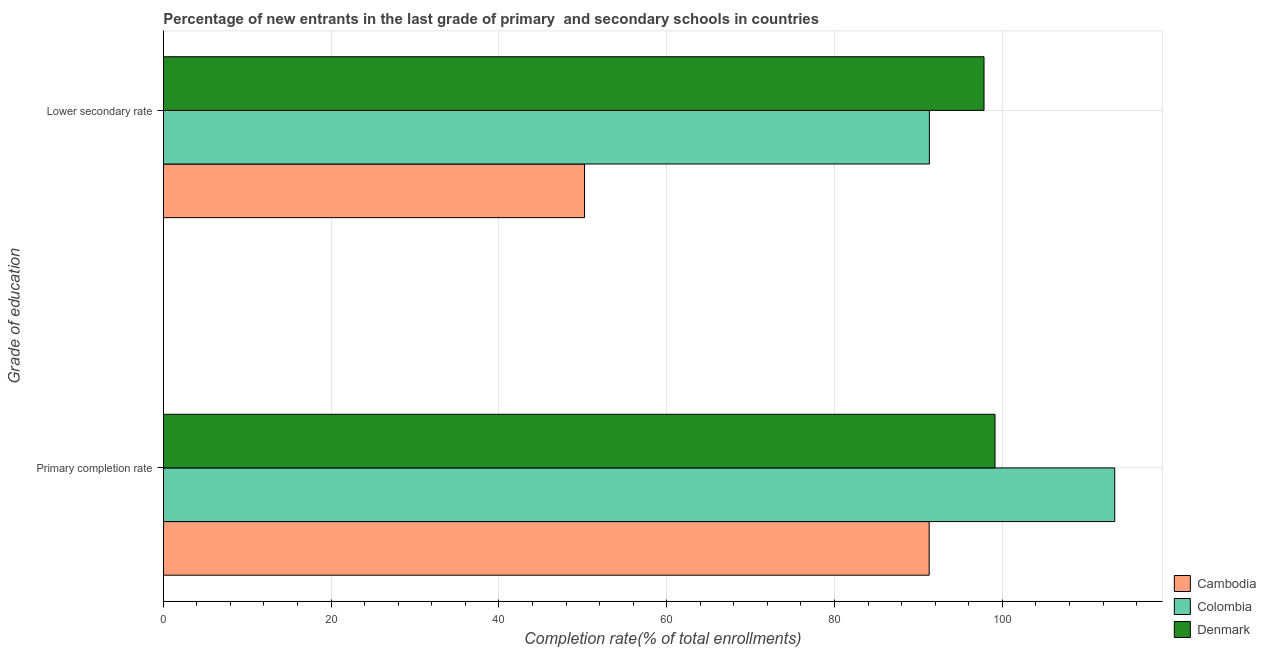How many different coloured bars are there?
Provide a short and direct response. 3. Are the number of bars per tick equal to the number of legend labels?
Provide a succinct answer. Yes. Are the number of bars on each tick of the Y-axis equal?
Your answer should be compact. Yes. How many bars are there on the 1st tick from the top?
Your answer should be very brief. 3. How many bars are there on the 2nd tick from the bottom?
Offer a very short reply. 3. What is the label of the 1st group of bars from the top?
Keep it short and to the point. Lower secondary rate. What is the completion rate in secondary schools in Cambodia?
Ensure brevity in your answer.  50.21. Across all countries, what is the maximum completion rate in primary schools?
Your response must be concise. 113.39. Across all countries, what is the minimum completion rate in secondary schools?
Provide a succinct answer. 50.21. In which country was the completion rate in primary schools maximum?
Ensure brevity in your answer.  Colombia. In which country was the completion rate in primary schools minimum?
Ensure brevity in your answer.  Cambodia. What is the total completion rate in secondary schools in the graph?
Your answer should be compact. 239.32. What is the difference between the completion rate in secondary schools in Colombia and that in Denmark?
Offer a terse response. -6.51. What is the difference between the completion rate in primary schools in Denmark and the completion rate in secondary schools in Colombia?
Your answer should be compact. 7.82. What is the average completion rate in secondary schools per country?
Offer a very short reply. 79.77. What is the difference between the completion rate in primary schools and completion rate in secondary schools in Colombia?
Ensure brevity in your answer.  22.09. What is the ratio of the completion rate in primary schools in Denmark to that in Colombia?
Offer a terse response. 0.87. Is the completion rate in secondary schools in Colombia less than that in Cambodia?
Offer a terse response. No. What does the 2nd bar from the top in Primary completion rate represents?
Your answer should be compact. Colombia. How many bars are there?
Offer a terse response. 6. Are all the bars in the graph horizontal?
Your response must be concise. Yes. Are the values on the major ticks of X-axis written in scientific E-notation?
Your answer should be compact. No. Does the graph contain any zero values?
Your answer should be compact. No. Where does the legend appear in the graph?
Your answer should be very brief. Bottom right. How are the legend labels stacked?
Your response must be concise. Vertical. What is the title of the graph?
Offer a very short reply. Percentage of new entrants in the last grade of primary  and secondary schools in countries. Does "Trinidad and Tobago" appear as one of the legend labels in the graph?
Offer a very short reply. No. What is the label or title of the X-axis?
Offer a terse response. Completion rate(% of total enrollments). What is the label or title of the Y-axis?
Give a very brief answer. Grade of education. What is the Completion rate(% of total enrollments) of Cambodia in Primary completion rate?
Make the answer very short. 91.28. What is the Completion rate(% of total enrollments) in Colombia in Primary completion rate?
Offer a terse response. 113.39. What is the Completion rate(% of total enrollments) of Denmark in Primary completion rate?
Your answer should be compact. 99.12. What is the Completion rate(% of total enrollments) of Cambodia in Lower secondary rate?
Your response must be concise. 50.21. What is the Completion rate(% of total enrollments) of Colombia in Lower secondary rate?
Offer a very short reply. 91.3. What is the Completion rate(% of total enrollments) of Denmark in Lower secondary rate?
Make the answer very short. 97.81. Across all Grade of education, what is the maximum Completion rate(% of total enrollments) in Cambodia?
Make the answer very short. 91.28. Across all Grade of education, what is the maximum Completion rate(% of total enrollments) of Colombia?
Keep it short and to the point. 113.39. Across all Grade of education, what is the maximum Completion rate(% of total enrollments) in Denmark?
Your response must be concise. 99.12. Across all Grade of education, what is the minimum Completion rate(% of total enrollments) of Cambodia?
Ensure brevity in your answer.  50.21. Across all Grade of education, what is the minimum Completion rate(% of total enrollments) in Colombia?
Offer a very short reply. 91.3. Across all Grade of education, what is the minimum Completion rate(% of total enrollments) of Denmark?
Provide a succinct answer. 97.81. What is the total Completion rate(% of total enrollments) of Cambodia in the graph?
Provide a succinct answer. 141.48. What is the total Completion rate(% of total enrollments) of Colombia in the graph?
Ensure brevity in your answer.  204.7. What is the total Completion rate(% of total enrollments) in Denmark in the graph?
Provide a short and direct response. 196.94. What is the difference between the Completion rate(% of total enrollments) in Cambodia in Primary completion rate and that in Lower secondary rate?
Offer a very short reply. 41.07. What is the difference between the Completion rate(% of total enrollments) of Colombia in Primary completion rate and that in Lower secondary rate?
Keep it short and to the point. 22.09. What is the difference between the Completion rate(% of total enrollments) in Denmark in Primary completion rate and that in Lower secondary rate?
Provide a succinct answer. 1.31. What is the difference between the Completion rate(% of total enrollments) in Cambodia in Primary completion rate and the Completion rate(% of total enrollments) in Colombia in Lower secondary rate?
Offer a terse response. -0.02. What is the difference between the Completion rate(% of total enrollments) in Cambodia in Primary completion rate and the Completion rate(% of total enrollments) in Denmark in Lower secondary rate?
Offer a very short reply. -6.54. What is the difference between the Completion rate(% of total enrollments) of Colombia in Primary completion rate and the Completion rate(% of total enrollments) of Denmark in Lower secondary rate?
Ensure brevity in your answer.  15.58. What is the average Completion rate(% of total enrollments) in Cambodia per Grade of education?
Offer a very short reply. 70.74. What is the average Completion rate(% of total enrollments) in Colombia per Grade of education?
Your answer should be compact. 102.35. What is the average Completion rate(% of total enrollments) of Denmark per Grade of education?
Your response must be concise. 98.47. What is the difference between the Completion rate(% of total enrollments) in Cambodia and Completion rate(% of total enrollments) in Colombia in Primary completion rate?
Keep it short and to the point. -22.12. What is the difference between the Completion rate(% of total enrollments) of Cambodia and Completion rate(% of total enrollments) of Denmark in Primary completion rate?
Ensure brevity in your answer.  -7.85. What is the difference between the Completion rate(% of total enrollments) of Colombia and Completion rate(% of total enrollments) of Denmark in Primary completion rate?
Your response must be concise. 14.27. What is the difference between the Completion rate(% of total enrollments) of Cambodia and Completion rate(% of total enrollments) of Colombia in Lower secondary rate?
Give a very brief answer. -41.1. What is the difference between the Completion rate(% of total enrollments) of Cambodia and Completion rate(% of total enrollments) of Denmark in Lower secondary rate?
Make the answer very short. -47.61. What is the difference between the Completion rate(% of total enrollments) of Colombia and Completion rate(% of total enrollments) of Denmark in Lower secondary rate?
Your response must be concise. -6.51. What is the ratio of the Completion rate(% of total enrollments) in Cambodia in Primary completion rate to that in Lower secondary rate?
Your response must be concise. 1.82. What is the ratio of the Completion rate(% of total enrollments) of Colombia in Primary completion rate to that in Lower secondary rate?
Keep it short and to the point. 1.24. What is the ratio of the Completion rate(% of total enrollments) in Denmark in Primary completion rate to that in Lower secondary rate?
Your response must be concise. 1.01. What is the difference between the highest and the second highest Completion rate(% of total enrollments) of Cambodia?
Offer a terse response. 41.07. What is the difference between the highest and the second highest Completion rate(% of total enrollments) in Colombia?
Offer a terse response. 22.09. What is the difference between the highest and the second highest Completion rate(% of total enrollments) in Denmark?
Provide a succinct answer. 1.31. What is the difference between the highest and the lowest Completion rate(% of total enrollments) of Cambodia?
Your answer should be compact. 41.07. What is the difference between the highest and the lowest Completion rate(% of total enrollments) in Colombia?
Keep it short and to the point. 22.09. What is the difference between the highest and the lowest Completion rate(% of total enrollments) of Denmark?
Keep it short and to the point. 1.31. 